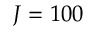<formula> <loc_0><loc_0><loc_500><loc_500>J = 1 0 0</formula> 